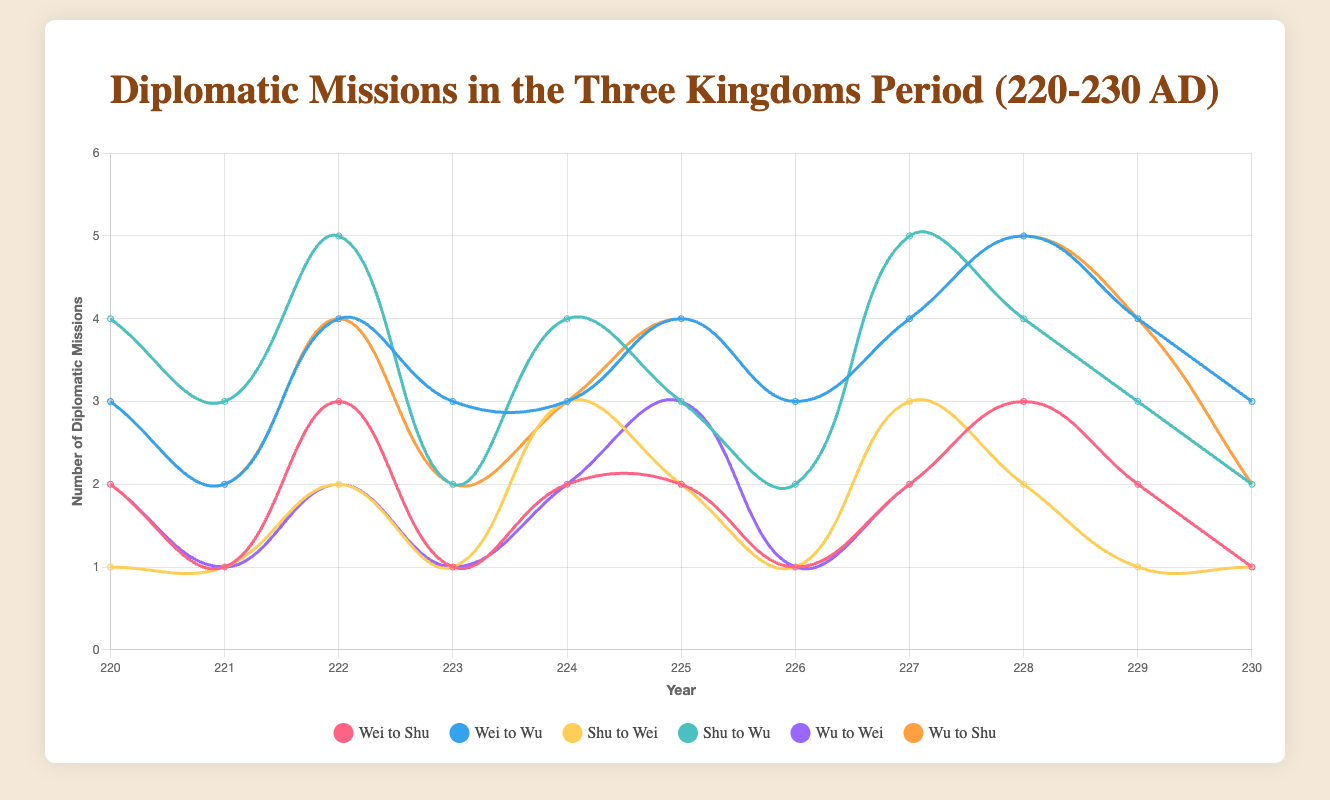How many diplomatic missions did Shu send to Wu in 222 AD? The figure shows Shu's diplomatic missions to Wu in 222 AD as indicated by the corresponding point on the line labeled 'Shu to Wu'. From the data point on the chart, we can observe the value.
Answer: 5 In which year did Wei send the highest number of missions to Wu? By examining the 'Wei to Wu' line on the chart, we identify the highest peak. The highest number of missions is reached in 228, with 5 missions.
Answer: 228 Which direction had more diplomatic missions overall in 223 AD: Wei to Shu or Wu to Wei? To compare, examine the heights of the two data points for the year 223 on the respective lines 'Wei to Shu' and 'Wu to Wei'. In 223, Wei to Shu had 1 mission, and Wu to Wei had 1 mission.
Answer: Equal What is the average number of missions Shu sent to Wei each year? Adding the number of missions Shu sent to Wei for each year from 220 to 230 (1+1+2+1+3+2+1+3+2+1+1) gives a total of 18. Dividing by the 11 years, the average is 18/11.
Answer: 1.64 Did Wei ever send 4 missions to Shu in any single year between 220 and 230 AD? By examining the 'Wei to Shu' line, we check to see if there is any point that reaches the value 4. There is no such point; the maximum is 3 missions.
Answer: No How many years did Shu send exactly 2 missions to Wu? By counting the number of data points for the 'Shu to Wu' line that reach the value 2, we observe the years are 223, 225, 226, and 230. This happens 4 times.
Answer: 4 Which kingdom received more missions from Wu in 228 AD: Wei or Shu? Compare the heights of the data points for the year 228 on the 'Wu to Wei' and 'Wu to Shu' lines. 'Wu to Wei' has 3 missions, while 'Wu to Shu' has 5.
Answer: Shu In which year did Wu receive the same number of diplomatic missions from Wei and Shu? We look for a year where the data points on 'Wei to Wu' and 'Shu to Wu' lines are equal. In 226, both lines show 3 missions.
Answer: 226 What's the total number of diplomatic missions sent by Wei to Shu and Wu in 222 AD? Sum up Wei to Shu and Wei to Wu numbers for 222. Wei to Shu is 3 and Wei to Wu is 4, so the total is 3+4.
Answer: 7 